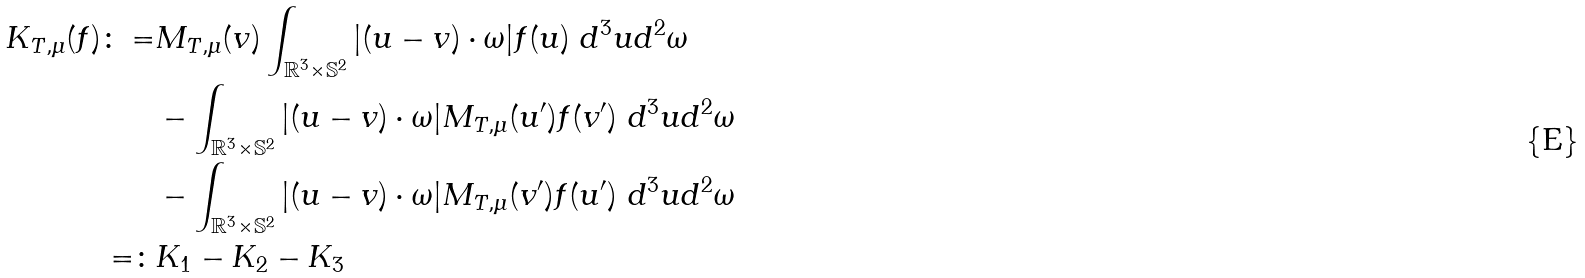<formula> <loc_0><loc_0><loc_500><loc_500>K _ { T , \mu } ( f ) \colon = & M _ { T , \mu } ( v ) \int _ { \mathbb { R } ^ { 3 } \times \mathbb { S } ^ { 2 } } | ( u - v ) \cdot \omega | f ( u ) \ d ^ { 3 } u d ^ { 2 } \omega \\ & - \int _ { \mathbb { R } ^ { 3 } \times \mathbb { S } ^ { 2 } } | ( u - v ) \cdot \omega | M _ { T , \mu } ( u ^ { \prime } ) f ( v ^ { \prime } ) \ d ^ { 3 } u d ^ { 2 } \omega \\ & - \int _ { \mathbb { R } ^ { 3 } \times \mathbb { S } ^ { 2 } } | ( u - v ) \cdot \omega | M _ { T , \mu } ( v ^ { \prime } ) f ( u ^ { \prime } ) \ d ^ { 3 } u d ^ { 2 } \omega \\ = \colon & K _ { 1 } - K _ { 2 } - K _ { 3 }</formula> 